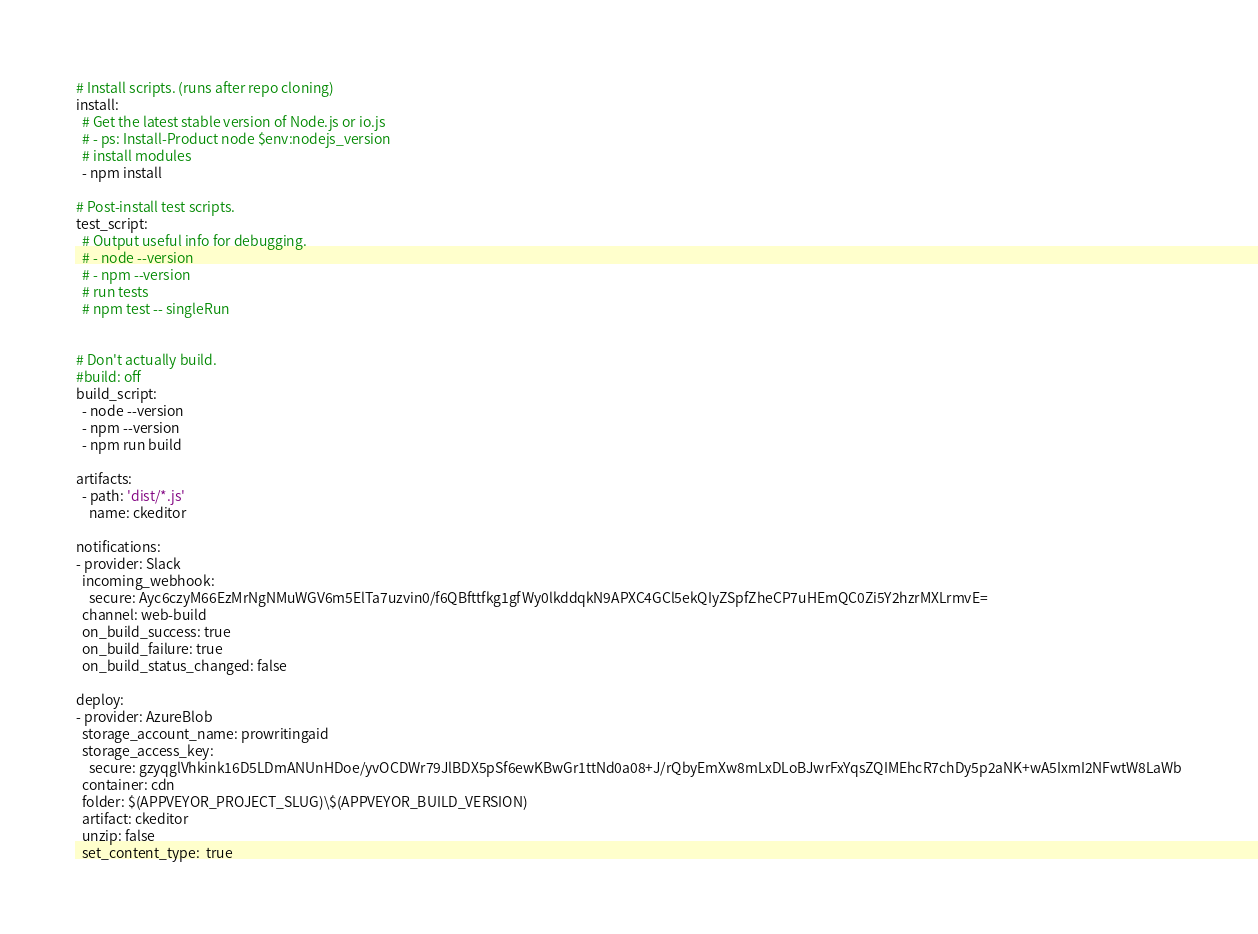<code> <loc_0><loc_0><loc_500><loc_500><_YAML_># Install scripts. (runs after repo cloning)
install:
  # Get the latest stable version of Node.js or io.js
  # - ps: Install-Product node $env:nodejs_version
  # install modules
  - npm install

# Post-install test scripts.
test_script:
  # Output useful info for debugging.
  # - node --version
  # - npm --version
  # run tests
  # npm test -- singleRun
  

# Don't actually build.
#build: off
build_script:
  - node --version
  - npm --version
  - npm run build
  
artifacts:
  - path: 'dist/*.js'
    name: ckeditor

notifications:
- provider: Slack
  incoming_webhook: 
    secure: Ayc6czyM66EzMrNgNMuWGV6m5ElTa7uzvin0/f6QBfttfkg1gfWy0lkddqkN9APXC4GCl5ekQIyZSpfZheCP7uHEmQC0Zi5Y2hzrMXLrmvE=
  channel: web-build
  on_build_success: true
  on_build_failure: true
  on_build_status_changed: false
  
deploy:
- provider: AzureBlob
  storage_account_name: prowritingaid
  storage_access_key: 
    secure: gzyqglVhkink16D5LDmANUnHDoe/yvOCDWr79JlBDX5pSf6ewKBwGr1ttNd0a08+J/rQbyEmXw8mLxDLoBJwrFxYqsZQIMEhcR7chDy5p2aNK+wA5IxmI2NFwtW8LaWb
  container: cdn
  folder: $(APPVEYOR_PROJECT_SLUG)\$(APPVEYOR_BUILD_VERSION)
  artifact: ckeditor
  unzip: false
  set_content_type:  true
</code> 